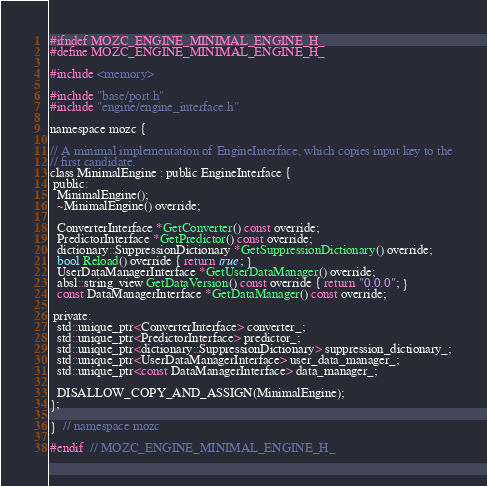<code> <loc_0><loc_0><loc_500><loc_500><_C_>
#ifndef MOZC_ENGINE_MINIMAL_ENGINE_H_
#define MOZC_ENGINE_MINIMAL_ENGINE_H_

#include <memory>

#include "base/port.h"
#include "engine/engine_interface.h"

namespace mozc {

// A minimal implementation of EngineInterface, which copies input key to the
// first candidate.
class MinimalEngine : public EngineInterface {
 public:
  MinimalEngine();
  ~MinimalEngine() override;

  ConverterInterface *GetConverter() const override;
  PredictorInterface *GetPredictor() const override;
  dictionary::SuppressionDictionary *GetSuppressionDictionary() override;
  bool Reload() override { return true; }
  UserDataManagerInterface *GetUserDataManager() override;
  absl::string_view GetDataVersion() const override { return "0.0.0"; }
  const DataManagerInterface *GetDataManager() const override;

 private:
  std::unique_ptr<ConverterInterface> converter_;
  std::unique_ptr<PredictorInterface> predictor_;
  std::unique_ptr<dictionary::SuppressionDictionary> suppression_dictionary_;
  std::unique_ptr<UserDataManagerInterface> user_data_manager_;
  std::unique_ptr<const DataManagerInterface> data_manager_;

  DISALLOW_COPY_AND_ASSIGN(MinimalEngine);
};

}  // namespace mozc

#endif  // MOZC_ENGINE_MINIMAL_ENGINE_H_
</code> 